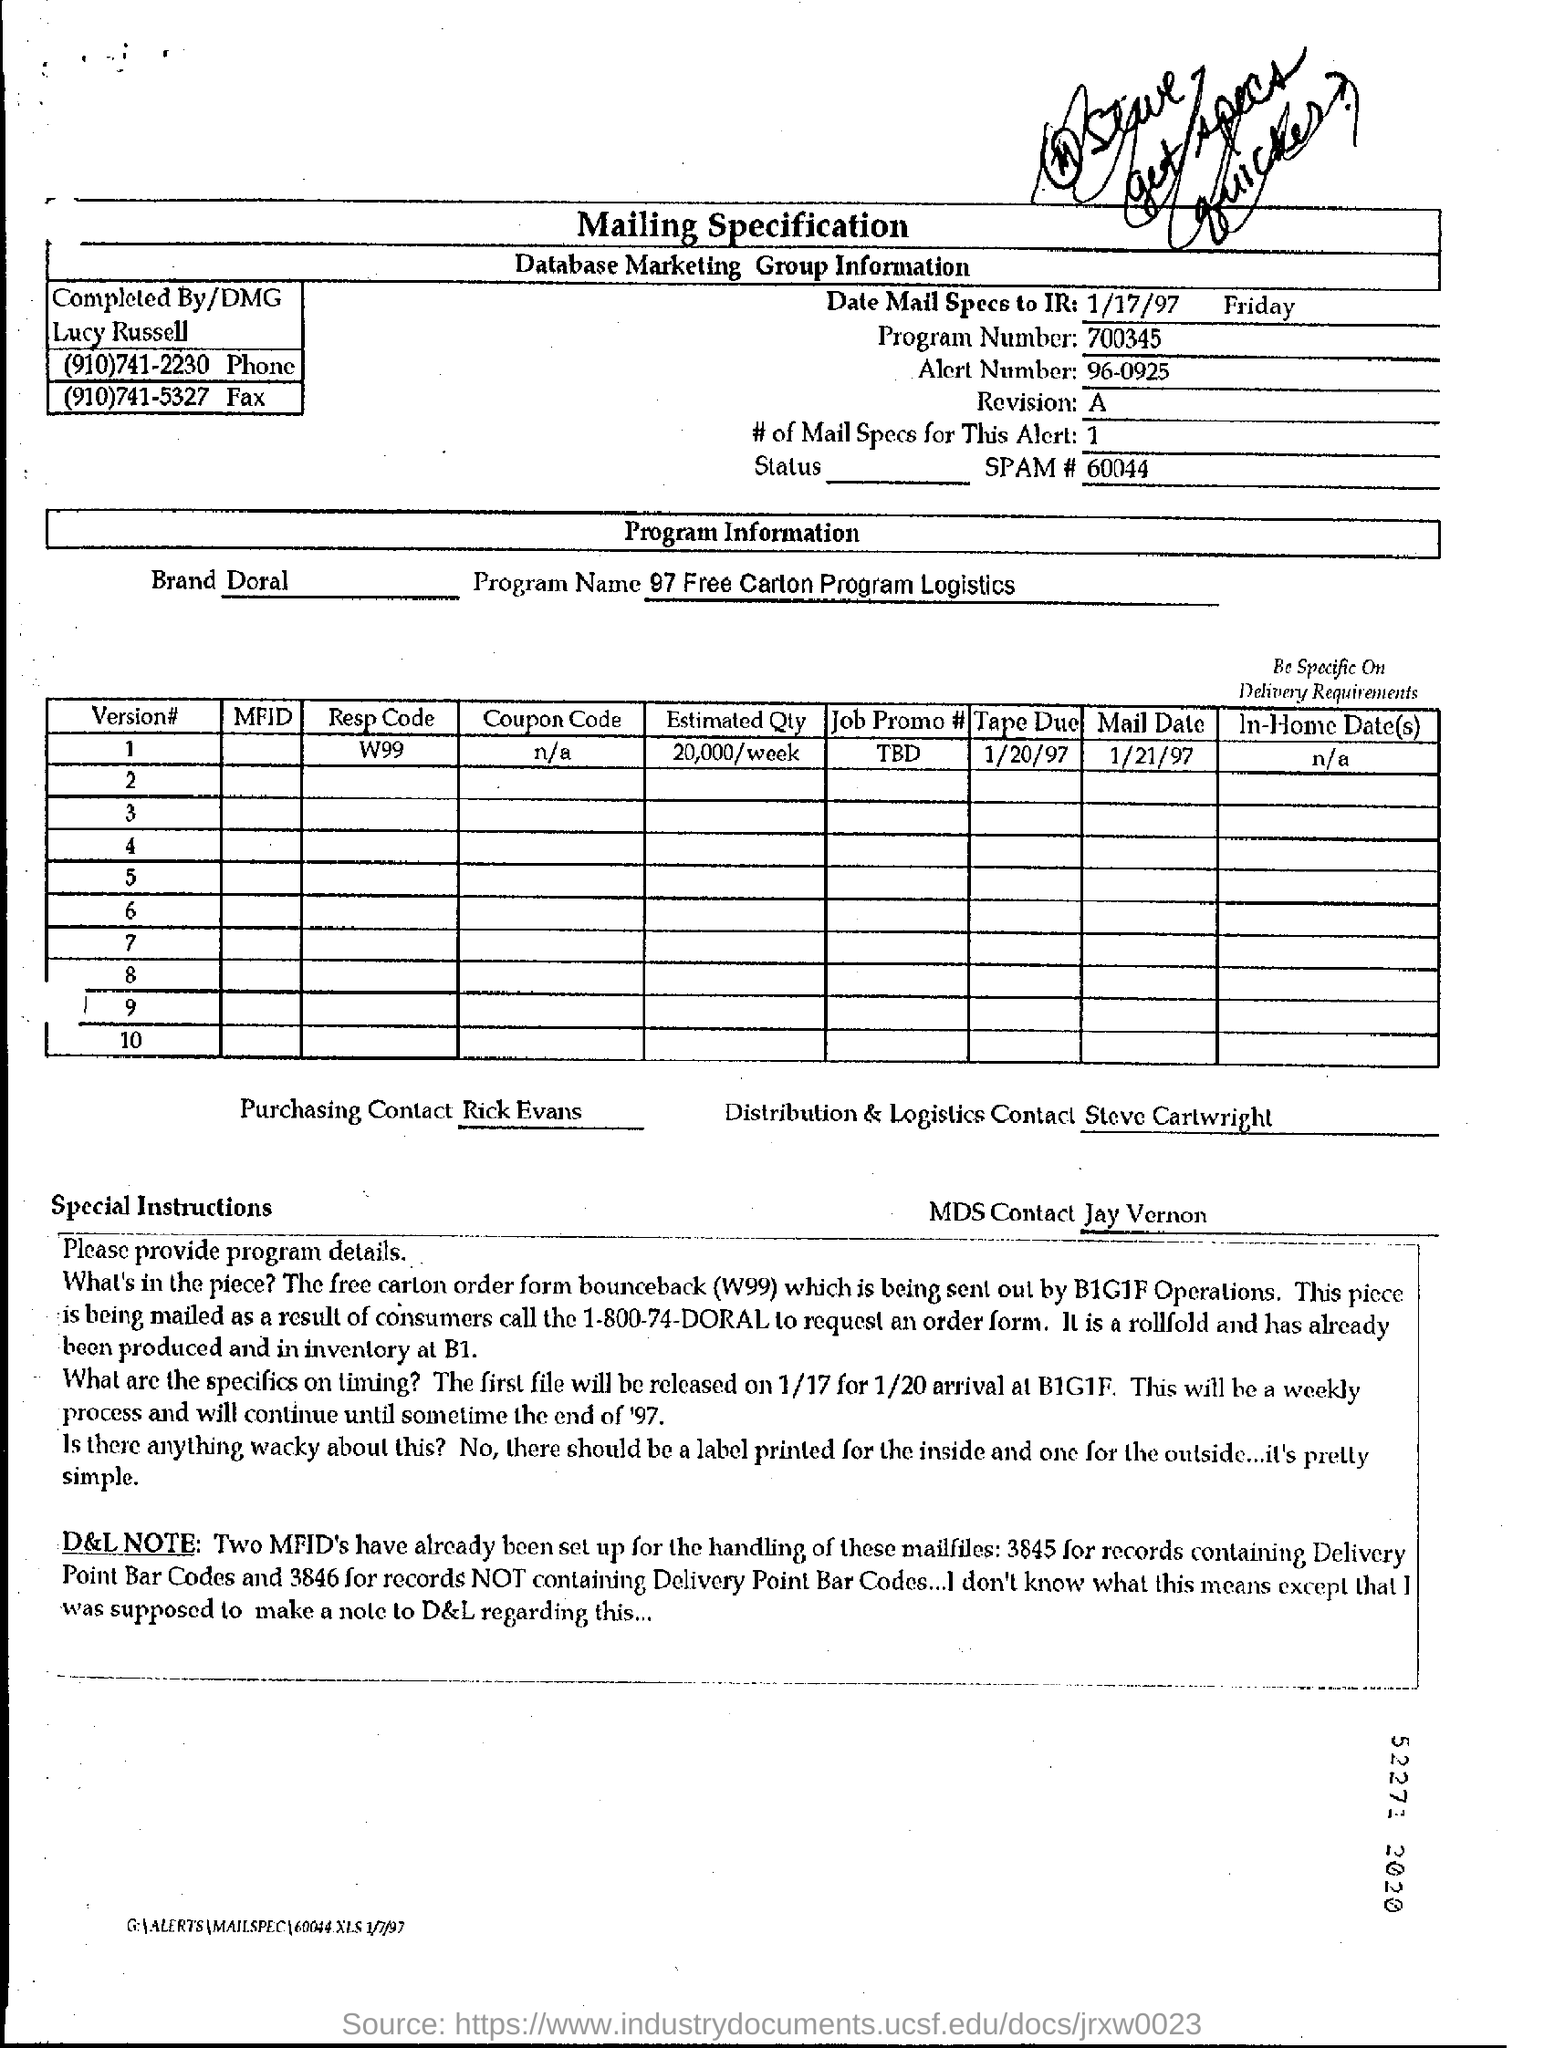What is the Program Name ?
Offer a terse response. 97 Free Carton Program Logistics. What is the Brand Name ?
Provide a short and direct response. Doral. What is the Program Number ?
Give a very brief answer. Program Number:700345. What is the Resp Code for version 1 ?
Your answer should be compact. W99. 